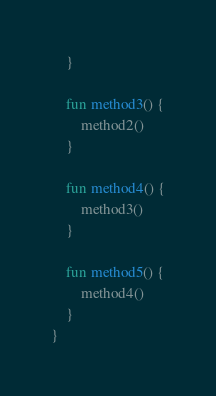<code> <loc_0><loc_0><loc_500><loc_500><_Kotlin_>    }

    fun method3() {
        method2()
    }

    fun method4() {
        method3()
    }

    fun method5() {
        method4()
    }
}
</code> 